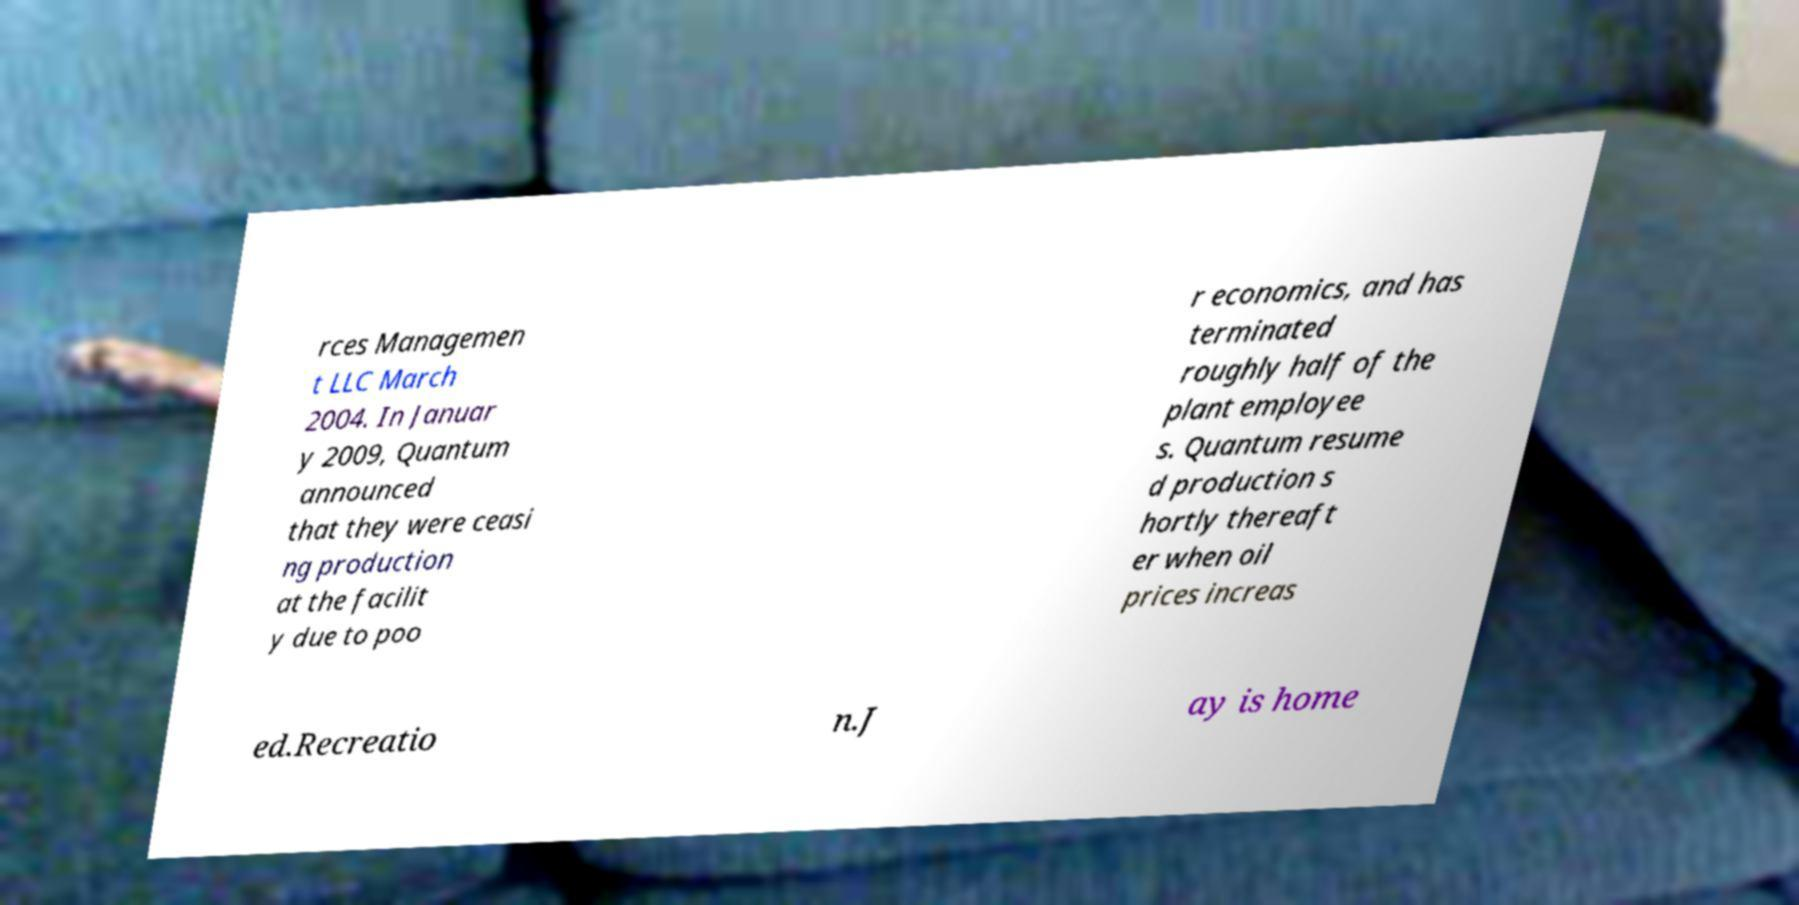Could you extract and type out the text from this image? rces Managemen t LLC March 2004. In Januar y 2009, Quantum announced that they were ceasi ng production at the facilit y due to poo r economics, and has terminated roughly half of the plant employee s. Quantum resume d production s hortly thereaft er when oil prices increas ed.Recreatio n.J ay is home 